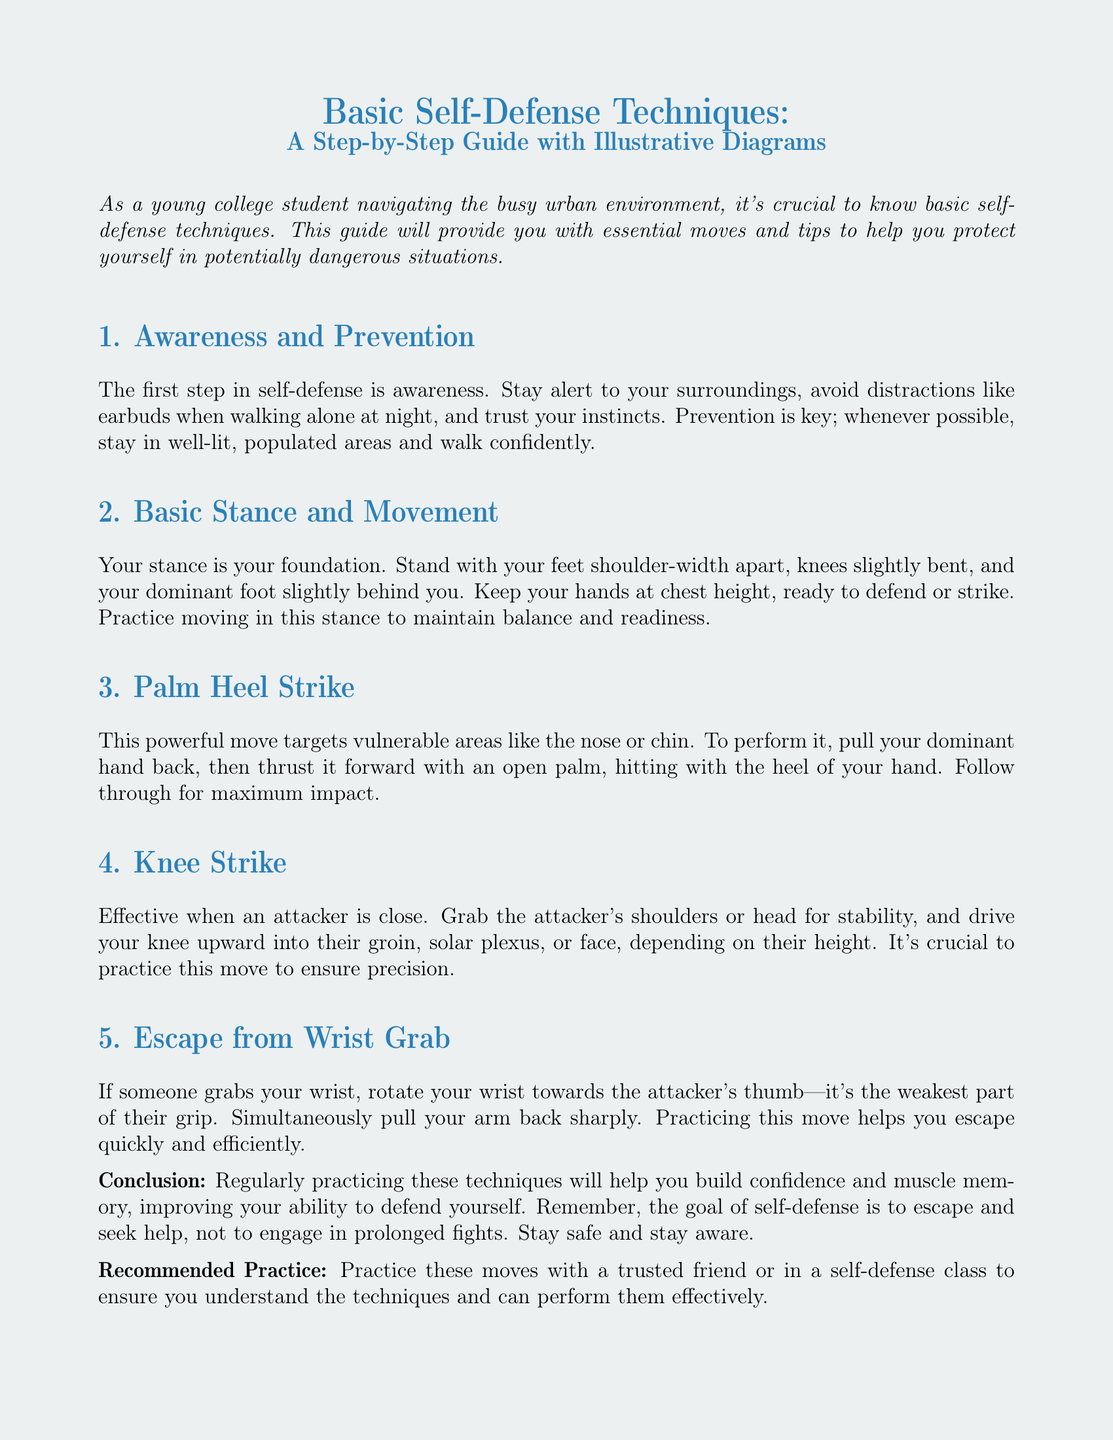What is the title of the document? The title is prominently displayed at the top of the document, summarizing the content.
Answer: Basic Self-Defense Techniques: A Step-by-Step Guide with Illustrative Diagrams What is the first step in self-defense? The document outlines the key steps in self-defense, starting with awareness.
Answer: Awareness What should you avoid when walking alone at night? The document advises on precautions to take during nighttime walks for safety and awareness.
Answer: Distractions What move targets the nose or chin? The guide specifically mentions a technique meant to strike vulnerable areas.
Answer: Palm Heel Strike What part of the body should you target with a knee strike? The document describes the areas where a knee strike can be effectively executed.
Answer: Groin What should you rotate your wrist towards to escape a wrist grab? The document explains how to escape a wrist grab focusing on the attacker's grip weakness.
Answer: Thumb What is the goal of self-defense according to the document? The conclusion provides the primary objective of self-defense techniques discussed.
Answer: Escape Who should you practice self-defense moves with? The document recommends practicing with a trusted companion or in a class setting.
Answer: Trusted friend How does the document suggest you should stand for self-defense? The guide provides details on the appropriate standing position for self-defense readiness.
Answer: Shoulder-width apart 